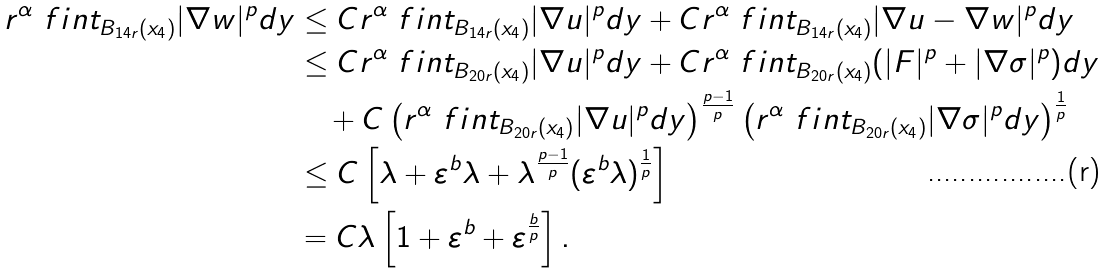Convert formula to latex. <formula><loc_0><loc_0><loc_500><loc_500>r ^ { \alpha } \ f i n t _ { B _ { 1 4 r } ( x _ { 4 } ) } { | \nabla w | ^ { p } d y } & \leq C r ^ { \alpha } \ f i n t _ { B _ { 1 4 r } ( x _ { 4 } ) } { | \nabla u | ^ { p } d y } + C r ^ { \alpha } \ f i n t _ { B _ { 1 4 r } ( x _ { 4 } ) } { | \nabla u - \nabla w | ^ { p } d y } \\ & \leq C r ^ { \alpha } \ f i n t _ { B _ { 2 0 r } ( x _ { 4 } ) } { | \nabla u | ^ { p } d y } + C r ^ { \alpha } \ f i n t _ { B _ { 2 0 r } ( x _ { 4 } ) } { ( | F | ^ { p } + | \nabla \sigma | ^ { p } ) d y } \\ & \quad + C \left ( r ^ { \alpha } \ f i n t _ { B _ { 2 0 r } ( x _ { 4 } ) } { | \nabla u | ^ { p } d y } \right ) ^ { \frac { p - 1 } { p } } \left ( r ^ { \alpha } \ f i n t _ { B _ { 2 0 r } ( x _ { 4 } ) } { | \nabla \sigma | ^ { p } d y } \right ) ^ { \frac { 1 } { p } } \\ & \leq C \left [ \lambda + \varepsilon ^ { b } \lambda + \lambda ^ { \frac { p - 1 } { p } } ( \varepsilon ^ { b } \lambda ) ^ { \frac { 1 } { p } } \right ] \\ & = C \lambda \left [ 1 + \varepsilon ^ { b } + \varepsilon ^ { \frac { b } { p } } \right ] .</formula> 